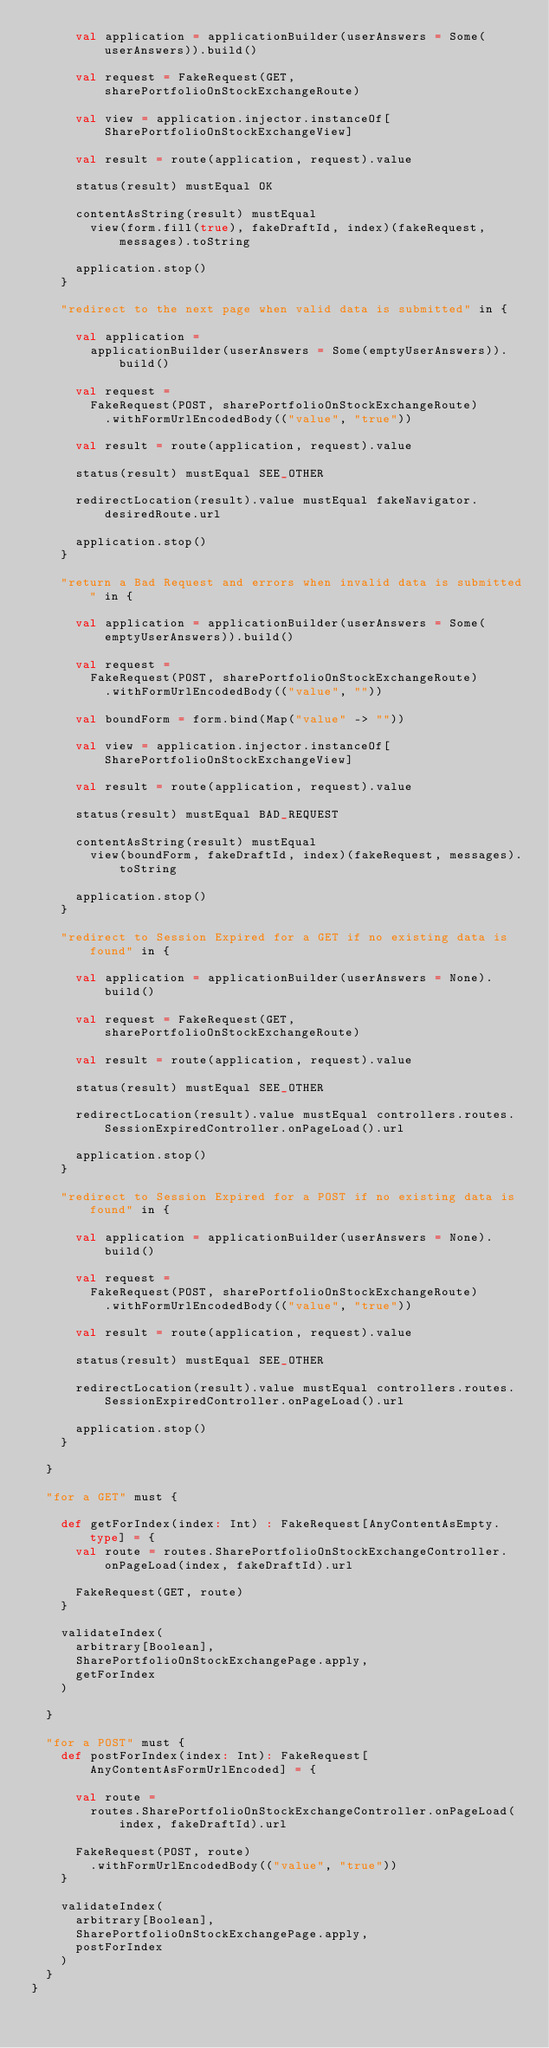<code> <loc_0><loc_0><loc_500><loc_500><_Scala_>      val application = applicationBuilder(userAnswers = Some(userAnswers)).build()

      val request = FakeRequest(GET, sharePortfolioOnStockExchangeRoute)

      val view = application.injector.instanceOf[SharePortfolioOnStockExchangeView]

      val result = route(application, request).value

      status(result) mustEqual OK

      contentAsString(result) mustEqual
        view(form.fill(true), fakeDraftId, index)(fakeRequest, messages).toString

      application.stop()
    }

    "redirect to the next page when valid data is submitted" in {

      val application =
        applicationBuilder(userAnswers = Some(emptyUserAnswers)).build()

      val request =
        FakeRequest(POST, sharePortfolioOnStockExchangeRoute)
          .withFormUrlEncodedBody(("value", "true"))

      val result = route(application, request).value

      status(result) mustEqual SEE_OTHER

      redirectLocation(result).value mustEqual fakeNavigator.desiredRoute.url

      application.stop()
    }

    "return a Bad Request and errors when invalid data is submitted" in {

      val application = applicationBuilder(userAnswers = Some(emptyUserAnswers)).build()

      val request =
        FakeRequest(POST, sharePortfolioOnStockExchangeRoute)
          .withFormUrlEncodedBody(("value", ""))

      val boundForm = form.bind(Map("value" -> ""))

      val view = application.injector.instanceOf[SharePortfolioOnStockExchangeView]

      val result = route(application, request).value

      status(result) mustEqual BAD_REQUEST

      contentAsString(result) mustEqual
        view(boundForm, fakeDraftId, index)(fakeRequest, messages).toString

      application.stop()
    }

    "redirect to Session Expired for a GET if no existing data is found" in {

      val application = applicationBuilder(userAnswers = None).build()

      val request = FakeRequest(GET, sharePortfolioOnStockExchangeRoute)

      val result = route(application, request).value

      status(result) mustEqual SEE_OTHER

      redirectLocation(result).value mustEqual controllers.routes.SessionExpiredController.onPageLoad().url

      application.stop()
    }

    "redirect to Session Expired for a POST if no existing data is found" in {

      val application = applicationBuilder(userAnswers = None).build()

      val request =
        FakeRequest(POST, sharePortfolioOnStockExchangeRoute)
          .withFormUrlEncodedBody(("value", "true"))

      val result = route(application, request).value

      status(result) mustEqual SEE_OTHER

      redirectLocation(result).value mustEqual controllers.routes.SessionExpiredController.onPageLoad().url

      application.stop()
    }

  }

  "for a GET" must {

    def getForIndex(index: Int) : FakeRequest[AnyContentAsEmpty.type] = {
      val route = routes.SharePortfolioOnStockExchangeController.onPageLoad(index, fakeDraftId).url

      FakeRequest(GET, route)
    }

    validateIndex(
      arbitrary[Boolean],
      SharePortfolioOnStockExchangePage.apply,
      getForIndex
    )

  }

  "for a POST" must {
    def postForIndex(index: Int): FakeRequest[AnyContentAsFormUrlEncoded] = {

      val route =
        routes.SharePortfolioOnStockExchangeController.onPageLoad(index, fakeDraftId).url

      FakeRequest(POST, route)
        .withFormUrlEncodedBody(("value", "true"))
    }

    validateIndex(
      arbitrary[Boolean],
      SharePortfolioOnStockExchangePage.apply,
      postForIndex
    )
  }
}
</code> 